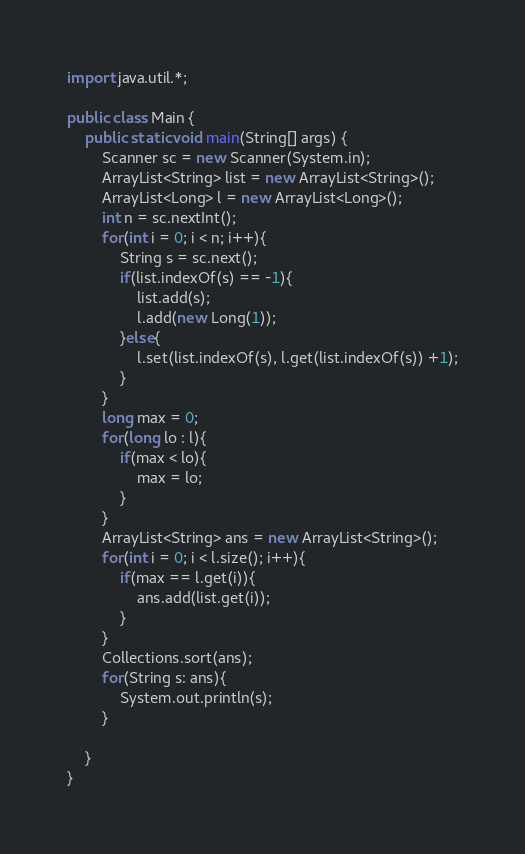<code> <loc_0><loc_0><loc_500><loc_500><_Java_>import java.util.*;

public class Main {
    public static void main(String[] args) {
        Scanner sc = new Scanner(System.in);
        ArrayList<String> list = new ArrayList<String>();
        ArrayList<Long> l = new ArrayList<Long>();
        int n = sc.nextInt();
        for(int i = 0; i < n; i++){
            String s = sc.next();
            if(list.indexOf(s) == -1){
                list.add(s);
                l.add(new Long(1));
            }else{
                l.set(list.indexOf(s), l.get(list.indexOf(s)) +1);
            }
        }
        long max = 0;
        for(long lo : l){
            if(max < lo){
                max = lo;
            }
        }
        ArrayList<String> ans = new ArrayList<String>();
        for(int i = 0; i < l.size(); i++){
            if(max == l.get(i)){
                ans.add(list.get(i));
            }
        }
        Collections.sort(ans);
        for(String s: ans){
            System.out.println(s);
        }
        
    }
}
</code> 